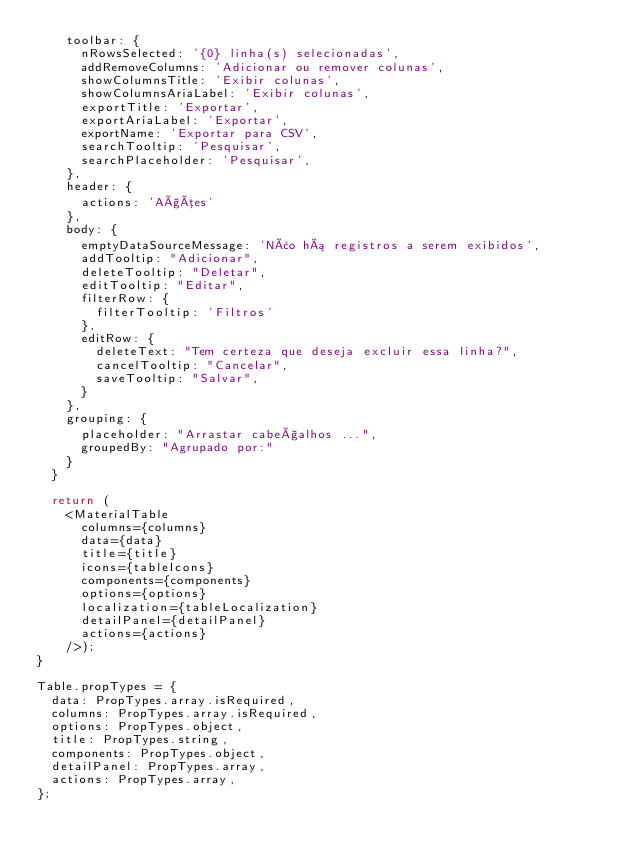Convert code to text. <code><loc_0><loc_0><loc_500><loc_500><_JavaScript_>    toolbar: {
      nRowsSelected: '{0} linha(s) selecionadas',
      addRemoveColumns: 'Adicionar ou remover colunas',
      showColumnsTitle: 'Exibir colunas',
      showColumnsAriaLabel: 'Exibir colunas',
      exportTitle: 'Exportar',
      exportAriaLabel: 'Exportar',
      exportName: 'Exportar para CSV',
      searchTooltip: 'Pesquisar',
      searchPlaceholder: 'Pesquisar',
    },
    header: {
      actions: 'Ações'
    },
    body: {
      emptyDataSourceMessage: 'Não há registros a serem exibidos',
      addTooltip: "Adicionar",
      deleteTooltip: "Deletar",
      editTooltip: "Editar",
      filterRow: {
        filterTooltip: 'Filtros'
      },
      editRow: {
        deleteText: "Tem certeza que deseja excluir essa linha?",
        cancelTooltip: "Cancelar",
        saveTooltip: "Salvar",
      }
    },
    grouping: {
      placeholder: "Arrastar cabeçalhos ...",
      groupedBy: "Agrupado por:"
    }
  }

  return (
    <MaterialTable
      columns={columns}
      data={data}
      title={title}
      icons={tableIcons}
      components={components}
      options={options}
      localization={tableLocalization}
      detailPanel={detailPanel}
      actions={actions}
    />);
}

Table.propTypes = {
  data: PropTypes.array.isRequired,
  columns: PropTypes.array.isRequired,
  options: PropTypes.object,
  title: PropTypes.string,
  components: PropTypes.object,
  detailPanel: PropTypes.array,
  actions: PropTypes.array,
};
</code> 